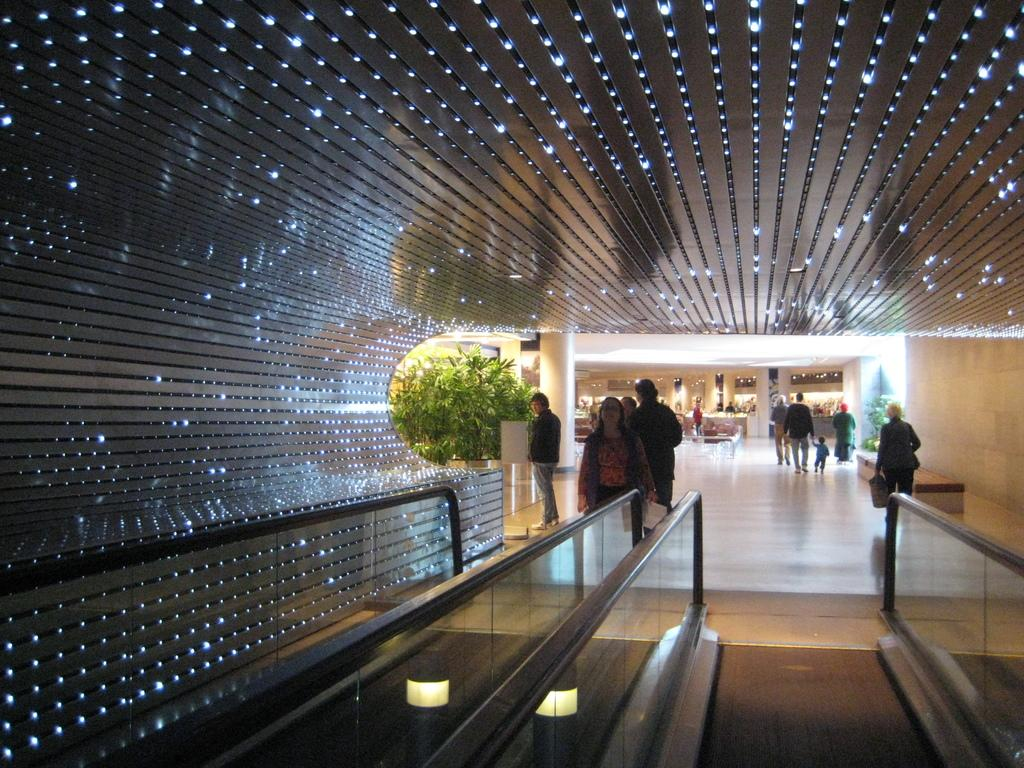What can be seen on the right side of the image? There are people and plants on the right side of the image. What is present on the left side of the image? There are plants on the left side of the image. What structure is located at the bottom side of the image? There is an elevator at the bottom side of the image. How many wrens are perched on the line in the image? There are no wrens or lines present in the image. Which leg of the person on the right side of the image is visible? There are no visible legs of the people in the image, as they are not shown from the waist down. 